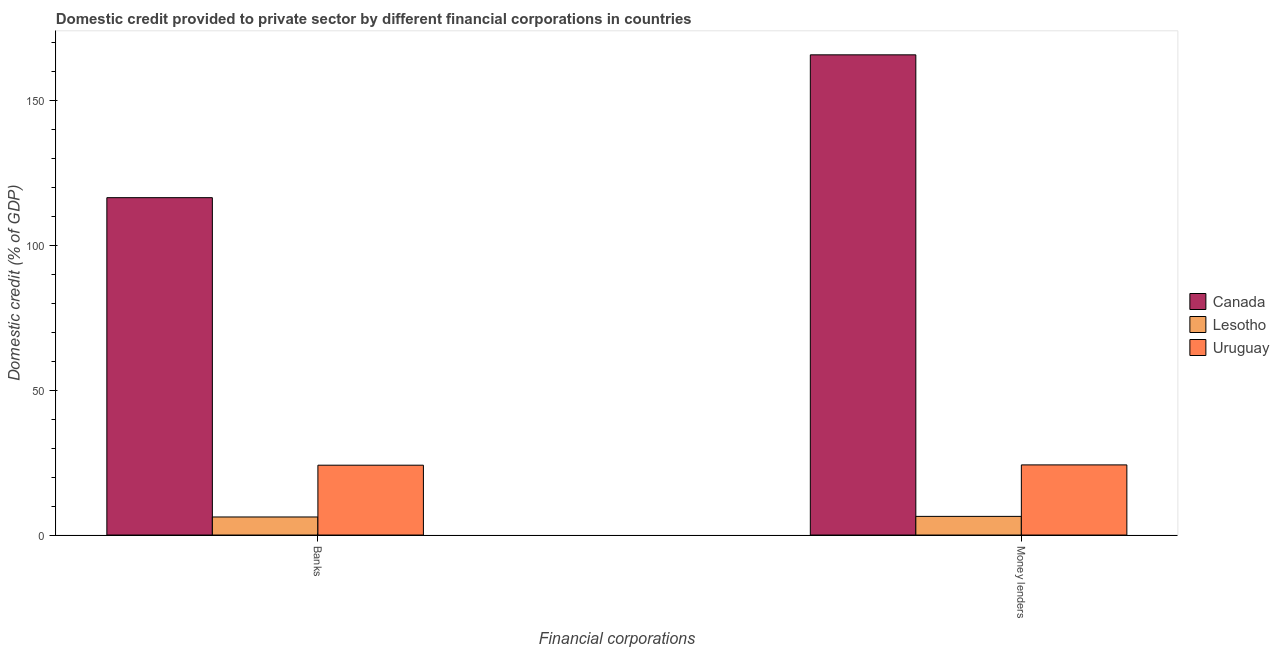How many different coloured bars are there?
Offer a terse response. 3. Are the number of bars per tick equal to the number of legend labels?
Your response must be concise. Yes. How many bars are there on the 2nd tick from the right?
Ensure brevity in your answer.  3. What is the label of the 1st group of bars from the left?
Your answer should be compact. Banks. What is the domestic credit provided by money lenders in Lesotho?
Ensure brevity in your answer.  6.44. Across all countries, what is the maximum domestic credit provided by money lenders?
Offer a terse response. 165.65. Across all countries, what is the minimum domestic credit provided by money lenders?
Your response must be concise. 6.44. In which country was the domestic credit provided by banks minimum?
Your response must be concise. Lesotho. What is the total domestic credit provided by banks in the graph?
Ensure brevity in your answer.  146.71. What is the difference between the domestic credit provided by money lenders in Uruguay and that in Lesotho?
Offer a terse response. 17.76. What is the difference between the domestic credit provided by money lenders in Lesotho and the domestic credit provided by banks in Uruguay?
Provide a succinct answer. -17.66. What is the average domestic credit provided by money lenders per country?
Ensure brevity in your answer.  65.43. What is the difference between the domestic credit provided by money lenders and domestic credit provided by banks in Canada?
Your response must be concise. 49.27. What is the ratio of the domestic credit provided by money lenders in Canada to that in Uruguay?
Provide a succinct answer. 6.85. What does the 2nd bar from the left in Money lenders represents?
Make the answer very short. Lesotho. How many bars are there?
Your answer should be very brief. 6. Are all the bars in the graph horizontal?
Your answer should be compact. No. Are the values on the major ticks of Y-axis written in scientific E-notation?
Ensure brevity in your answer.  No. Where does the legend appear in the graph?
Offer a very short reply. Center right. How many legend labels are there?
Offer a terse response. 3. How are the legend labels stacked?
Make the answer very short. Vertical. What is the title of the graph?
Keep it short and to the point. Domestic credit provided to private sector by different financial corporations in countries. Does "Lesotho" appear as one of the legend labels in the graph?
Offer a very short reply. Yes. What is the label or title of the X-axis?
Provide a short and direct response. Financial corporations. What is the label or title of the Y-axis?
Provide a succinct answer. Domestic credit (% of GDP). What is the Domestic credit (% of GDP) of Canada in Banks?
Provide a short and direct response. 116.38. What is the Domestic credit (% of GDP) of Lesotho in Banks?
Give a very brief answer. 6.23. What is the Domestic credit (% of GDP) of Uruguay in Banks?
Offer a terse response. 24.09. What is the Domestic credit (% of GDP) of Canada in Money lenders?
Your answer should be very brief. 165.65. What is the Domestic credit (% of GDP) in Lesotho in Money lenders?
Your answer should be compact. 6.44. What is the Domestic credit (% of GDP) of Uruguay in Money lenders?
Provide a succinct answer. 24.19. Across all Financial corporations, what is the maximum Domestic credit (% of GDP) of Canada?
Your response must be concise. 165.65. Across all Financial corporations, what is the maximum Domestic credit (% of GDP) in Lesotho?
Offer a terse response. 6.44. Across all Financial corporations, what is the maximum Domestic credit (% of GDP) of Uruguay?
Offer a terse response. 24.19. Across all Financial corporations, what is the minimum Domestic credit (% of GDP) of Canada?
Keep it short and to the point. 116.38. Across all Financial corporations, what is the minimum Domestic credit (% of GDP) of Lesotho?
Give a very brief answer. 6.23. Across all Financial corporations, what is the minimum Domestic credit (% of GDP) of Uruguay?
Make the answer very short. 24.09. What is the total Domestic credit (% of GDP) in Canada in the graph?
Provide a short and direct response. 282.03. What is the total Domestic credit (% of GDP) of Lesotho in the graph?
Keep it short and to the point. 12.67. What is the total Domestic credit (% of GDP) of Uruguay in the graph?
Keep it short and to the point. 48.29. What is the difference between the Domestic credit (% of GDP) of Canada in Banks and that in Money lenders?
Keep it short and to the point. -49.27. What is the difference between the Domestic credit (% of GDP) of Lesotho in Banks and that in Money lenders?
Provide a succinct answer. -0.2. What is the difference between the Domestic credit (% of GDP) of Uruguay in Banks and that in Money lenders?
Your answer should be compact. -0.1. What is the difference between the Domestic credit (% of GDP) in Canada in Banks and the Domestic credit (% of GDP) in Lesotho in Money lenders?
Offer a very short reply. 109.95. What is the difference between the Domestic credit (% of GDP) in Canada in Banks and the Domestic credit (% of GDP) in Uruguay in Money lenders?
Provide a succinct answer. 92.19. What is the difference between the Domestic credit (% of GDP) in Lesotho in Banks and the Domestic credit (% of GDP) in Uruguay in Money lenders?
Offer a terse response. -17.96. What is the average Domestic credit (% of GDP) of Canada per Financial corporations?
Keep it short and to the point. 141.02. What is the average Domestic credit (% of GDP) of Lesotho per Financial corporations?
Your answer should be very brief. 6.33. What is the average Domestic credit (% of GDP) in Uruguay per Financial corporations?
Offer a terse response. 24.14. What is the difference between the Domestic credit (% of GDP) in Canada and Domestic credit (% of GDP) in Lesotho in Banks?
Give a very brief answer. 110.15. What is the difference between the Domestic credit (% of GDP) in Canada and Domestic credit (% of GDP) in Uruguay in Banks?
Make the answer very short. 92.29. What is the difference between the Domestic credit (% of GDP) of Lesotho and Domestic credit (% of GDP) of Uruguay in Banks?
Ensure brevity in your answer.  -17.86. What is the difference between the Domestic credit (% of GDP) of Canada and Domestic credit (% of GDP) of Lesotho in Money lenders?
Your response must be concise. 159.21. What is the difference between the Domestic credit (% of GDP) of Canada and Domestic credit (% of GDP) of Uruguay in Money lenders?
Keep it short and to the point. 141.46. What is the difference between the Domestic credit (% of GDP) in Lesotho and Domestic credit (% of GDP) in Uruguay in Money lenders?
Offer a very short reply. -17.76. What is the ratio of the Domestic credit (% of GDP) in Canada in Banks to that in Money lenders?
Keep it short and to the point. 0.7. What is the ratio of the Domestic credit (% of GDP) of Lesotho in Banks to that in Money lenders?
Your response must be concise. 0.97. What is the difference between the highest and the second highest Domestic credit (% of GDP) of Canada?
Your answer should be compact. 49.27. What is the difference between the highest and the second highest Domestic credit (% of GDP) of Lesotho?
Your response must be concise. 0.2. What is the difference between the highest and the second highest Domestic credit (% of GDP) of Uruguay?
Your answer should be very brief. 0.1. What is the difference between the highest and the lowest Domestic credit (% of GDP) in Canada?
Your answer should be compact. 49.27. What is the difference between the highest and the lowest Domestic credit (% of GDP) of Lesotho?
Your answer should be compact. 0.2. What is the difference between the highest and the lowest Domestic credit (% of GDP) of Uruguay?
Your answer should be compact. 0.1. 